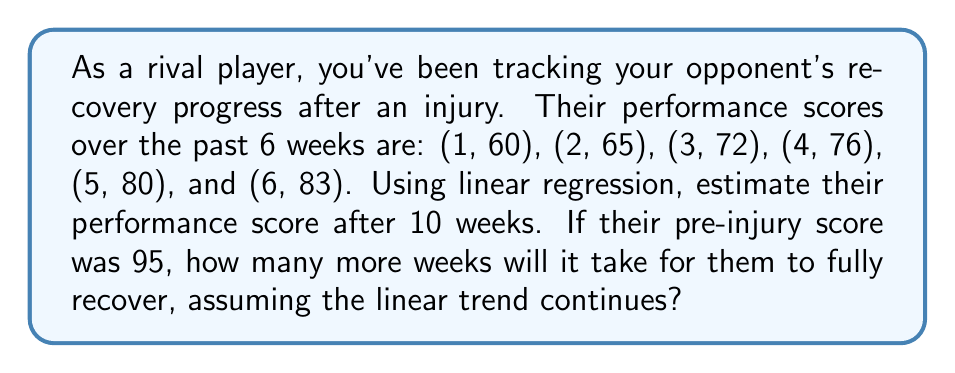Can you solve this math problem? 1) First, let's calculate the linear regression equation:
   Let $x$ represent weeks and $y$ represent performance score.
   
   $n = 6$
   $\sum x = 21$
   $\sum y = 436$
   $\sum xy = 1681$
   $\sum x^2 = 91$

   Slope $m = \frac{n\sum xy - \sum x \sum y}{n\sum x^2 - (\sum x)^2}$
   $= \frac{6(1681) - 21(436)}{6(91) - 21^2} = \frac{10086 - 9156}{546 - 441} = \frac{930}{105} = 4.857$

   Y-intercept $b = \frac{\sum y - m\sum x}{n} = \frac{436 - 4.857(21)}{6} = 57.143$

   Linear equation: $y = 4.857x + 57.143$

2) To estimate performance after 10 weeks:
   $y = 4.857(10) + 57.143 = 105.713$

3) To find weeks until full recovery:
   Set $y = 95$ (pre-injury score) and solve for $x$:
   $95 = 4.857x + 57.143$
   $37.857 = 4.857x$
   $x = 7.794$ weeks

4) Since they've already spent 6 weeks recovering, additional time needed:
   $7.794 - 6 = 1.794$ weeks
Answer: 105.71 (estimated score at 10 weeks); 1.79 additional weeks to full recovery 